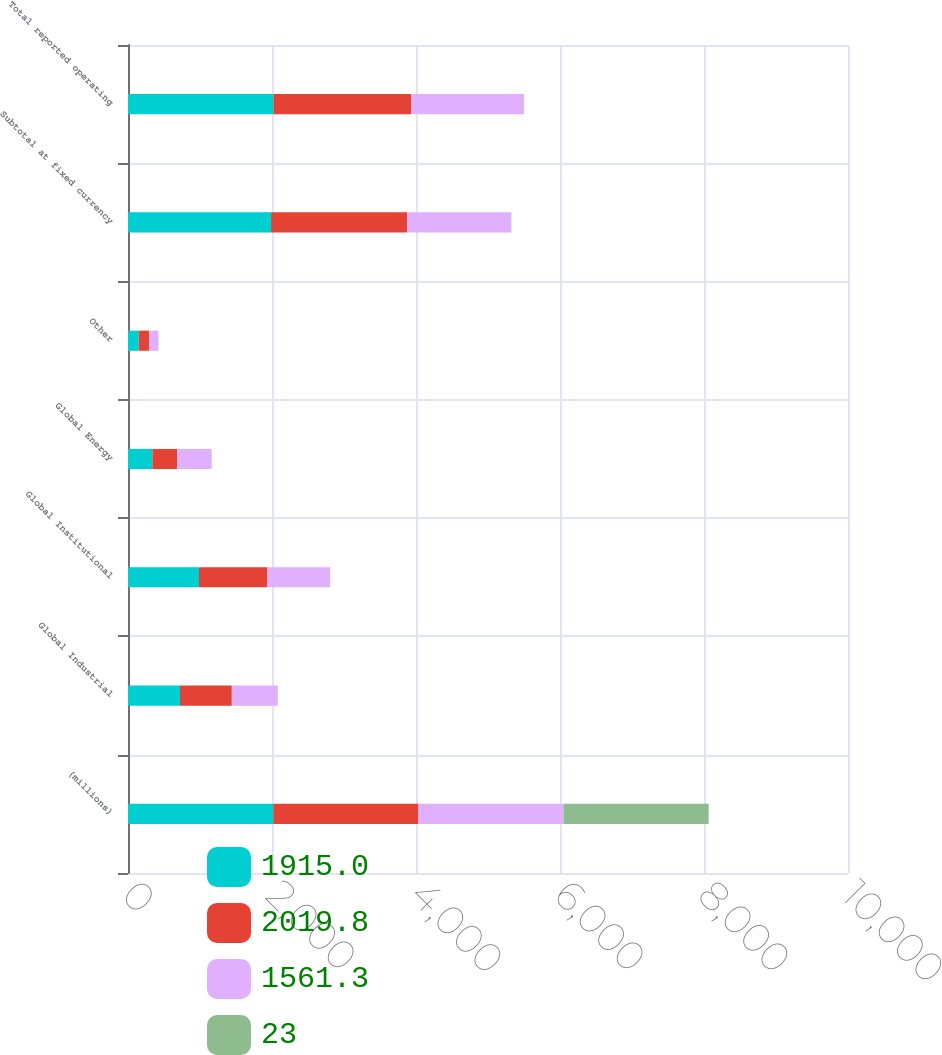<chart> <loc_0><loc_0><loc_500><loc_500><stacked_bar_chart><ecel><fcel>(millions)<fcel>Global Industrial<fcel>Global Institutional<fcel>Global Energy<fcel>Other<fcel>Subtotal at fixed currency<fcel>Total reported operating<nl><fcel>1915<fcel>2017<fcel>722<fcel>985.7<fcel>338.5<fcel>149.3<fcel>1986.9<fcel>2019.8<nl><fcel>2019.8<fcel>2016<fcel>720<fcel>950.5<fcel>346.7<fcel>145.2<fcel>1889.8<fcel>1915<nl><fcel>1561.3<fcel>2015<fcel>638.9<fcel>867.1<fcel>475.3<fcel>124.6<fcel>1441.5<fcel>1561.3<nl><fcel>23<fcel>2017<fcel>0<fcel>4<fcel>2<fcel>3<fcel>5<fcel>5<nl></chart> 